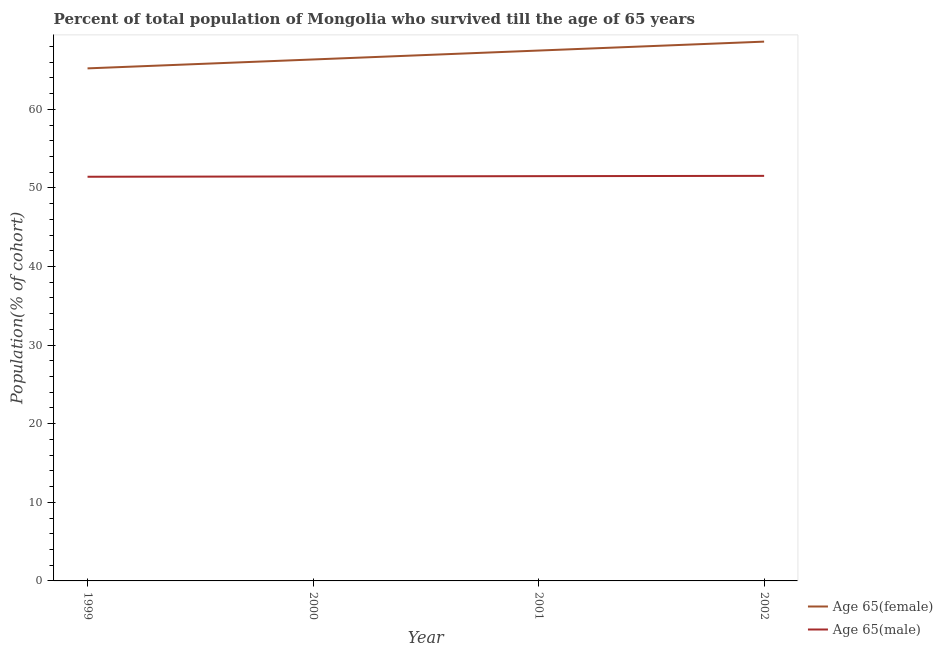How many different coloured lines are there?
Offer a terse response. 2. What is the percentage of female population who survived till age of 65 in 2000?
Offer a terse response. 66.34. Across all years, what is the maximum percentage of male population who survived till age of 65?
Your answer should be very brief. 51.53. Across all years, what is the minimum percentage of female population who survived till age of 65?
Your response must be concise. 65.2. In which year was the percentage of female population who survived till age of 65 maximum?
Give a very brief answer. 2002. What is the total percentage of female population who survived till age of 65 in the graph?
Give a very brief answer. 267.62. What is the difference between the percentage of male population who survived till age of 65 in 1999 and that in 2000?
Provide a succinct answer. -0.04. What is the difference between the percentage of male population who survived till age of 65 in 1999 and the percentage of female population who survived till age of 65 in 2002?
Your answer should be compact. -17.19. What is the average percentage of female population who survived till age of 65 per year?
Your response must be concise. 66.9. In the year 1999, what is the difference between the percentage of female population who survived till age of 65 and percentage of male population who survived till age of 65?
Ensure brevity in your answer.  13.79. In how many years, is the percentage of male population who survived till age of 65 greater than 50 %?
Give a very brief answer. 4. What is the ratio of the percentage of male population who survived till age of 65 in 2000 to that in 2002?
Provide a short and direct response. 1. Is the percentage of male population who survived till age of 65 in 2000 less than that in 2002?
Your answer should be very brief. Yes. Is the difference between the percentage of male population who survived till age of 65 in 1999 and 2001 greater than the difference between the percentage of female population who survived till age of 65 in 1999 and 2001?
Provide a short and direct response. Yes. What is the difference between the highest and the second highest percentage of female population who survived till age of 65?
Your answer should be compact. 1.13. What is the difference between the highest and the lowest percentage of male population who survived till age of 65?
Your answer should be compact. 0.11. In how many years, is the percentage of male population who survived till age of 65 greater than the average percentage of male population who survived till age of 65 taken over all years?
Your response must be concise. 2. How many years are there in the graph?
Your answer should be very brief. 4. Are the values on the major ticks of Y-axis written in scientific E-notation?
Keep it short and to the point. No. Where does the legend appear in the graph?
Your answer should be compact. Bottom right. How many legend labels are there?
Offer a very short reply. 2. How are the legend labels stacked?
Provide a succinct answer. Vertical. What is the title of the graph?
Make the answer very short. Percent of total population of Mongolia who survived till the age of 65 years. Does "From production" appear as one of the legend labels in the graph?
Provide a short and direct response. No. What is the label or title of the Y-axis?
Offer a terse response. Population(% of cohort). What is the Population(% of cohort) of Age 65(female) in 1999?
Your answer should be very brief. 65.2. What is the Population(% of cohort) in Age 65(male) in 1999?
Your answer should be compact. 51.42. What is the Population(% of cohort) in Age 65(female) in 2000?
Offer a very short reply. 66.34. What is the Population(% of cohort) in Age 65(male) in 2000?
Your answer should be compact. 51.45. What is the Population(% of cohort) in Age 65(female) in 2001?
Keep it short and to the point. 67.47. What is the Population(% of cohort) in Age 65(male) in 2001?
Provide a succinct answer. 51.49. What is the Population(% of cohort) in Age 65(female) in 2002?
Keep it short and to the point. 68.61. What is the Population(% of cohort) in Age 65(male) in 2002?
Your answer should be very brief. 51.53. Across all years, what is the maximum Population(% of cohort) of Age 65(female)?
Your answer should be very brief. 68.61. Across all years, what is the maximum Population(% of cohort) of Age 65(male)?
Your response must be concise. 51.53. Across all years, what is the minimum Population(% of cohort) in Age 65(female)?
Provide a succinct answer. 65.2. Across all years, what is the minimum Population(% of cohort) in Age 65(male)?
Your answer should be very brief. 51.42. What is the total Population(% of cohort) in Age 65(female) in the graph?
Make the answer very short. 267.62. What is the total Population(% of cohort) of Age 65(male) in the graph?
Your answer should be compact. 205.89. What is the difference between the Population(% of cohort) of Age 65(female) in 1999 and that in 2000?
Your answer should be compact. -1.13. What is the difference between the Population(% of cohort) in Age 65(male) in 1999 and that in 2000?
Offer a terse response. -0.04. What is the difference between the Population(% of cohort) of Age 65(female) in 1999 and that in 2001?
Provide a succinct answer. -2.27. What is the difference between the Population(% of cohort) of Age 65(male) in 1999 and that in 2001?
Your answer should be very brief. -0.08. What is the difference between the Population(% of cohort) in Age 65(female) in 1999 and that in 2002?
Make the answer very short. -3.4. What is the difference between the Population(% of cohort) of Age 65(male) in 1999 and that in 2002?
Your answer should be very brief. -0.11. What is the difference between the Population(% of cohort) in Age 65(female) in 2000 and that in 2001?
Offer a terse response. -1.13. What is the difference between the Population(% of cohort) of Age 65(male) in 2000 and that in 2001?
Give a very brief answer. -0.04. What is the difference between the Population(% of cohort) of Age 65(female) in 2000 and that in 2002?
Make the answer very short. -2.27. What is the difference between the Population(% of cohort) in Age 65(male) in 2000 and that in 2002?
Your answer should be compact. -0.08. What is the difference between the Population(% of cohort) in Age 65(female) in 2001 and that in 2002?
Make the answer very short. -1.13. What is the difference between the Population(% of cohort) in Age 65(male) in 2001 and that in 2002?
Your answer should be very brief. -0.04. What is the difference between the Population(% of cohort) in Age 65(female) in 1999 and the Population(% of cohort) in Age 65(male) in 2000?
Provide a short and direct response. 13.75. What is the difference between the Population(% of cohort) in Age 65(female) in 1999 and the Population(% of cohort) in Age 65(male) in 2001?
Make the answer very short. 13.71. What is the difference between the Population(% of cohort) in Age 65(female) in 1999 and the Population(% of cohort) in Age 65(male) in 2002?
Provide a succinct answer. 13.67. What is the difference between the Population(% of cohort) of Age 65(female) in 2000 and the Population(% of cohort) of Age 65(male) in 2001?
Give a very brief answer. 14.85. What is the difference between the Population(% of cohort) of Age 65(female) in 2000 and the Population(% of cohort) of Age 65(male) in 2002?
Give a very brief answer. 14.81. What is the difference between the Population(% of cohort) in Age 65(female) in 2001 and the Population(% of cohort) in Age 65(male) in 2002?
Offer a very short reply. 15.94. What is the average Population(% of cohort) in Age 65(female) per year?
Your answer should be very brief. 66.9. What is the average Population(% of cohort) in Age 65(male) per year?
Provide a succinct answer. 51.47. In the year 1999, what is the difference between the Population(% of cohort) of Age 65(female) and Population(% of cohort) of Age 65(male)?
Ensure brevity in your answer.  13.79. In the year 2000, what is the difference between the Population(% of cohort) of Age 65(female) and Population(% of cohort) of Age 65(male)?
Give a very brief answer. 14.88. In the year 2001, what is the difference between the Population(% of cohort) in Age 65(female) and Population(% of cohort) in Age 65(male)?
Keep it short and to the point. 15.98. In the year 2002, what is the difference between the Population(% of cohort) in Age 65(female) and Population(% of cohort) in Age 65(male)?
Your answer should be compact. 17.08. What is the ratio of the Population(% of cohort) of Age 65(female) in 1999 to that in 2000?
Ensure brevity in your answer.  0.98. What is the ratio of the Population(% of cohort) in Age 65(male) in 1999 to that in 2000?
Give a very brief answer. 1. What is the ratio of the Population(% of cohort) in Age 65(female) in 1999 to that in 2001?
Offer a terse response. 0.97. What is the ratio of the Population(% of cohort) in Age 65(male) in 1999 to that in 2001?
Your answer should be compact. 1. What is the ratio of the Population(% of cohort) in Age 65(female) in 1999 to that in 2002?
Your response must be concise. 0.95. What is the ratio of the Population(% of cohort) in Age 65(female) in 2000 to that in 2001?
Provide a succinct answer. 0.98. What is the ratio of the Population(% of cohort) of Age 65(male) in 2000 to that in 2001?
Provide a short and direct response. 1. What is the ratio of the Population(% of cohort) in Age 65(female) in 2000 to that in 2002?
Give a very brief answer. 0.97. What is the ratio of the Population(% of cohort) in Age 65(female) in 2001 to that in 2002?
Ensure brevity in your answer.  0.98. What is the ratio of the Population(% of cohort) of Age 65(male) in 2001 to that in 2002?
Your answer should be compact. 1. What is the difference between the highest and the second highest Population(% of cohort) of Age 65(female)?
Ensure brevity in your answer.  1.13. What is the difference between the highest and the second highest Population(% of cohort) in Age 65(male)?
Provide a short and direct response. 0.04. What is the difference between the highest and the lowest Population(% of cohort) of Age 65(female)?
Give a very brief answer. 3.4. What is the difference between the highest and the lowest Population(% of cohort) in Age 65(male)?
Make the answer very short. 0.11. 